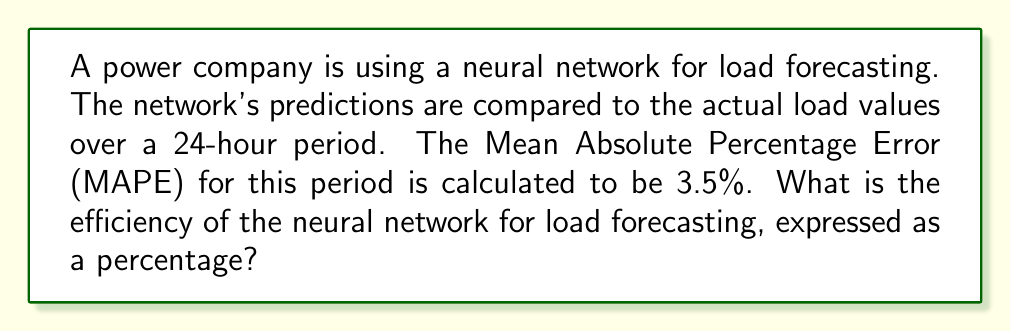Could you help me with this problem? To calculate the efficiency of a neural network for load forecasting, we need to understand that efficiency is typically expressed as a measure of how well the model performs. In this case, we're given the Mean Absolute Percentage Error (MAPE), which is a common metric for evaluating forecast accuracy.

The MAPE is calculated using the following formula:

$$ MAPE = \frac{1}{n} \sum_{i=1}^{n} \left| \frac{A_i - F_i}{A_i} \right| \times 100\% $$

Where:
$n$ is the number of observations
$A_i$ is the actual value
$F_i$ is the forecasted value

A lower MAPE indicates better performance. To convert MAPE to efficiency, we can use the following relationship:

$$ Efficiency = 100\% - MAPE $$

This relationship assumes that 0% MAPE would correspond to 100% efficiency (perfect prediction), and higher MAPE values result in lower efficiency.

Given:
MAPE = 3.5%

Calculating the efficiency:

$$ Efficiency = 100\% - 3.5\% = 96.5\% $$

Therefore, the efficiency of the neural network for load forecasting is 96.5%.
Answer: 96.5% 